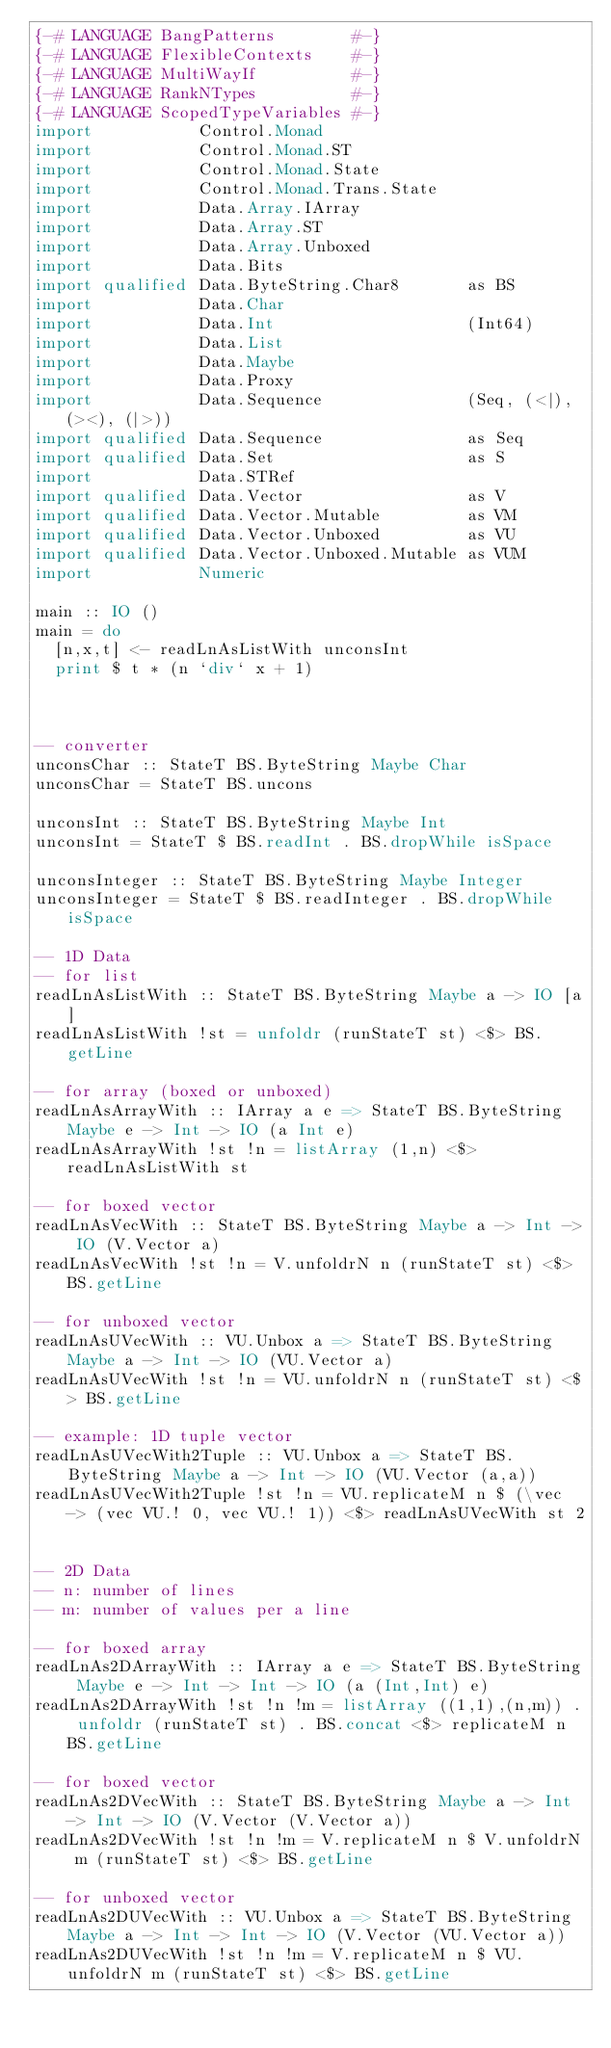Convert code to text. <code><loc_0><loc_0><loc_500><loc_500><_Haskell_>{-# LANGUAGE BangPatterns        #-}
{-# LANGUAGE FlexibleContexts    #-}
{-# LANGUAGE MultiWayIf          #-}
{-# LANGUAGE RankNTypes          #-}
{-# LANGUAGE ScopedTypeVariables #-}
import           Control.Monad
import           Control.Monad.ST
import           Control.Monad.State
import           Control.Monad.Trans.State
import           Data.Array.IArray
import           Data.Array.ST
import           Data.Array.Unboxed
import           Data.Bits
import qualified Data.ByteString.Char8       as BS
import           Data.Char
import           Data.Int                    (Int64)
import           Data.List
import           Data.Maybe
import           Data.Proxy
import           Data.Sequence               (Seq, (<|), (><), (|>))
import qualified Data.Sequence               as Seq
import qualified Data.Set                    as S
import           Data.STRef
import qualified Data.Vector                 as V
import qualified Data.Vector.Mutable         as VM
import qualified Data.Vector.Unboxed         as VU
import qualified Data.Vector.Unboxed.Mutable as VUM
import           Numeric

main :: IO ()
main = do
  [n,x,t] <- readLnAsListWith unconsInt
  print $ t * (n `div` x + 1)



-- converter
unconsChar :: StateT BS.ByteString Maybe Char
unconsChar = StateT BS.uncons

unconsInt :: StateT BS.ByteString Maybe Int
unconsInt = StateT $ BS.readInt . BS.dropWhile isSpace

unconsInteger :: StateT BS.ByteString Maybe Integer
unconsInteger = StateT $ BS.readInteger . BS.dropWhile isSpace

-- 1D Data
-- for list
readLnAsListWith :: StateT BS.ByteString Maybe a -> IO [a]
readLnAsListWith !st = unfoldr (runStateT st) <$> BS.getLine

-- for array (boxed or unboxed)
readLnAsArrayWith :: IArray a e => StateT BS.ByteString Maybe e -> Int -> IO (a Int e)
readLnAsArrayWith !st !n = listArray (1,n) <$> readLnAsListWith st

-- for boxed vector
readLnAsVecWith :: StateT BS.ByteString Maybe a -> Int -> IO (V.Vector a)
readLnAsVecWith !st !n = V.unfoldrN n (runStateT st) <$> BS.getLine

-- for unboxed vector
readLnAsUVecWith :: VU.Unbox a => StateT BS.ByteString Maybe a -> Int -> IO (VU.Vector a)
readLnAsUVecWith !st !n = VU.unfoldrN n (runStateT st) <$> BS.getLine

-- example: 1D tuple vector
readLnAsUVecWith2Tuple :: VU.Unbox a => StateT BS.ByteString Maybe a -> Int -> IO (VU.Vector (a,a))
readLnAsUVecWith2Tuple !st !n = VU.replicateM n $ (\vec -> (vec VU.! 0, vec VU.! 1)) <$> readLnAsUVecWith st 2


-- 2D Data
-- n: number of lines
-- m: number of values per a line

-- for boxed array
readLnAs2DArrayWith :: IArray a e => StateT BS.ByteString Maybe e -> Int -> Int -> IO (a (Int,Int) e)
readLnAs2DArrayWith !st !n !m = listArray ((1,1),(n,m)) . unfoldr (runStateT st) . BS.concat <$> replicateM n BS.getLine

-- for boxed vector
readLnAs2DVecWith :: StateT BS.ByteString Maybe a -> Int -> Int -> IO (V.Vector (V.Vector a))
readLnAs2DVecWith !st !n !m = V.replicateM n $ V.unfoldrN m (runStateT st) <$> BS.getLine

-- for unboxed vector
readLnAs2DUVecWith :: VU.Unbox a => StateT BS.ByteString Maybe a -> Int -> Int -> IO (V.Vector (VU.Vector a))
readLnAs2DUVecWith !st !n !m = V.replicateM n $ VU.unfoldrN m (runStateT st) <$> BS.getLine
</code> 